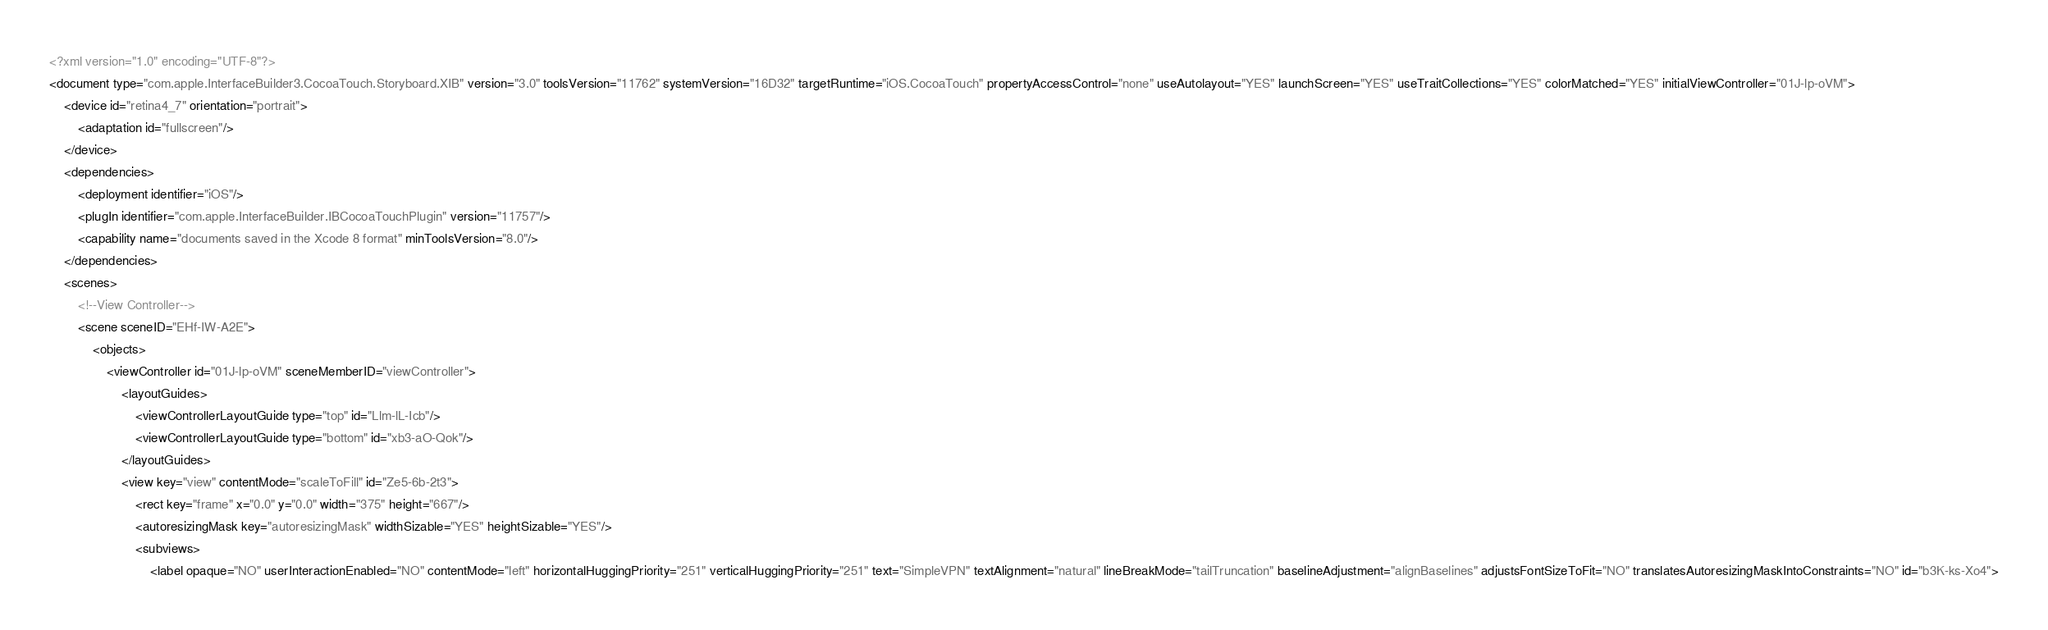Convert code to text. <code><loc_0><loc_0><loc_500><loc_500><_XML_><?xml version="1.0" encoding="UTF-8"?>
<document type="com.apple.InterfaceBuilder3.CocoaTouch.Storyboard.XIB" version="3.0" toolsVersion="11762" systemVersion="16D32" targetRuntime="iOS.CocoaTouch" propertyAccessControl="none" useAutolayout="YES" launchScreen="YES" useTraitCollections="YES" colorMatched="YES" initialViewController="01J-lp-oVM">
    <device id="retina4_7" orientation="portrait">
        <adaptation id="fullscreen"/>
    </device>
    <dependencies>
        <deployment identifier="iOS"/>
        <plugIn identifier="com.apple.InterfaceBuilder.IBCocoaTouchPlugin" version="11757"/>
        <capability name="documents saved in the Xcode 8 format" minToolsVersion="8.0"/>
    </dependencies>
    <scenes>
        <!--View Controller-->
        <scene sceneID="EHf-IW-A2E">
            <objects>
                <viewController id="01J-lp-oVM" sceneMemberID="viewController">
                    <layoutGuides>
                        <viewControllerLayoutGuide type="top" id="Llm-lL-Icb"/>
                        <viewControllerLayoutGuide type="bottom" id="xb3-aO-Qok"/>
                    </layoutGuides>
                    <view key="view" contentMode="scaleToFill" id="Ze5-6b-2t3">
                        <rect key="frame" x="0.0" y="0.0" width="375" height="667"/>
                        <autoresizingMask key="autoresizingMask" widthSizable="YES" heightSizable="YES"/>
                        <subviews>
                            <label opaque="NO" userInteractionEnabled="NO" contentMode="left" horizontalHuggingPriority="251" verticalHuggingPriority="251" text="SimpleVPN" textAlignment="natural" lineBreakMode="tailTruncation" baselineAdjustment="alignBaselines" adjustsFontSizeToFit="NO" translatesAutoresizingMaskIntoConstraints="NO" id="b3K-ks-Xo4"></code> 